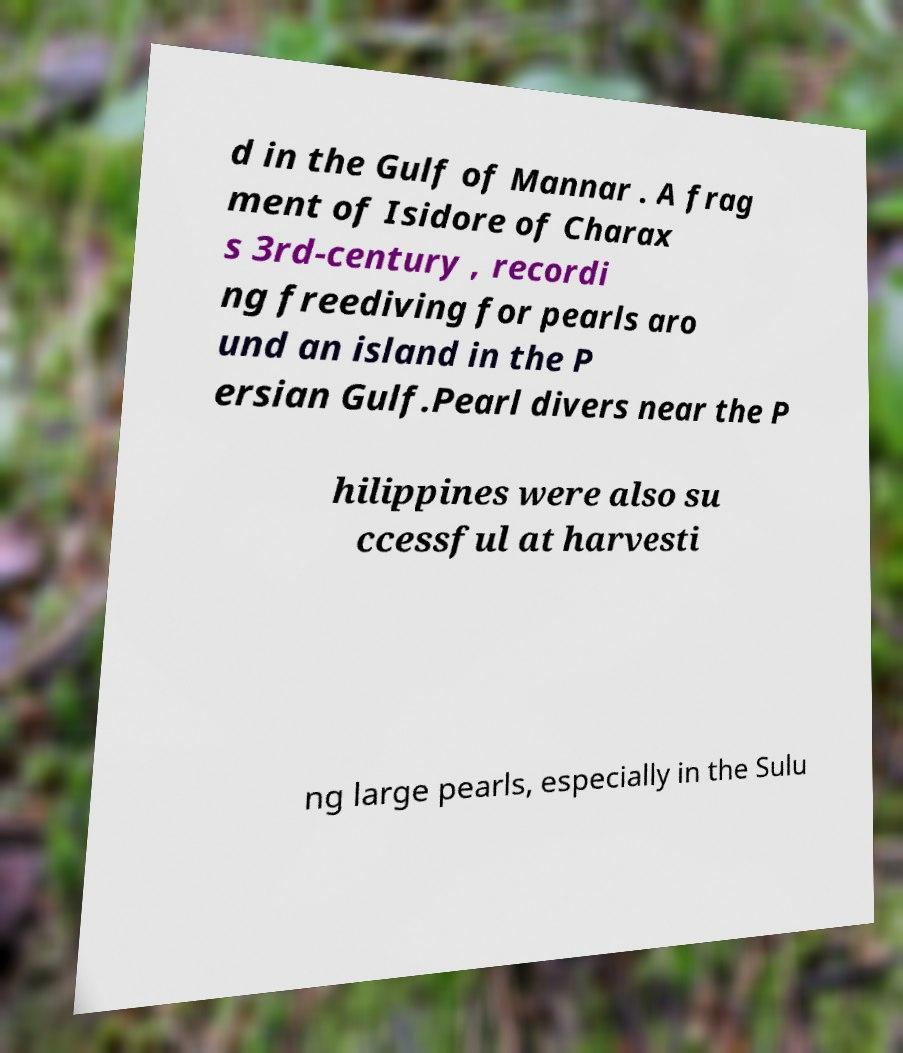There's text embedded in this image that I need extracted. Can you transcribe it verbatim? d in the Gulf of Mannar . A frag ment of Isidore of Charax s 3rd-century , recordi ng freediving for pearls aro und an island in the P ersian Gulf.Pearl divers near the P hilippines were also su ccessful at harvesti ng large pearls, especially in the Sulu 